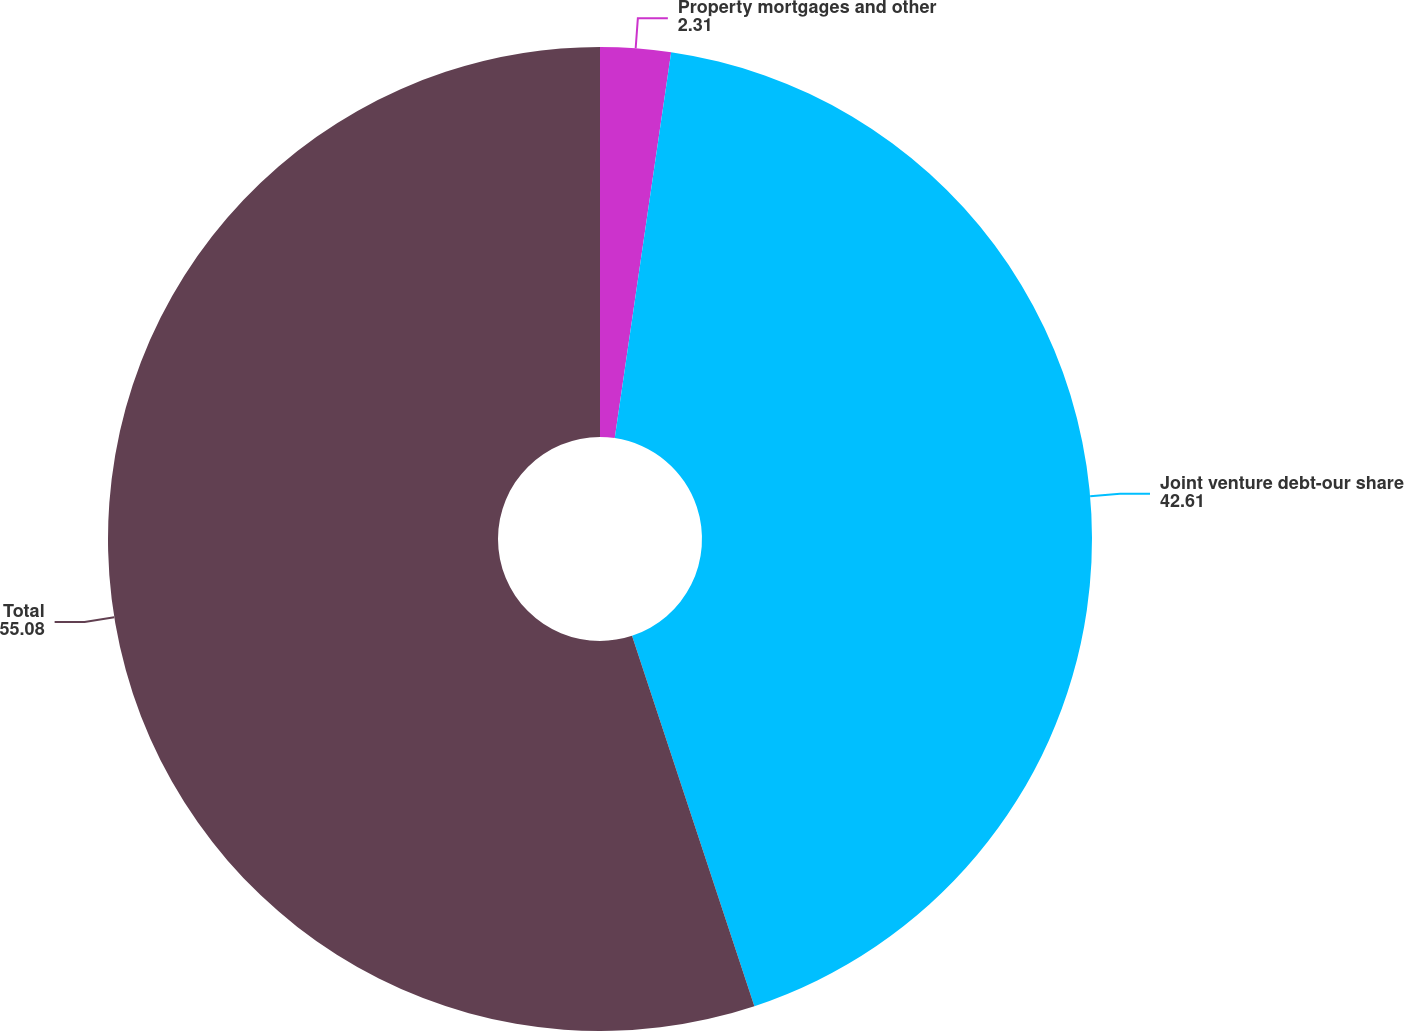Convert chart. <chart><loc_0><loc_0><loc_500><loc_500><pie_chart><fcel>Property mortgages and other<fcel>Joint venture debt-our share<fcel>Total<nl><fcel>2.31%<fcel>42.61%<fcel>55.08%<nl></chart> 